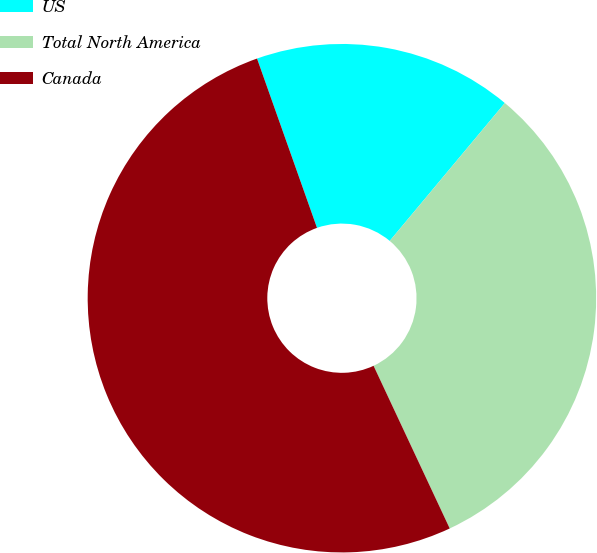Convert chart to OTSL. <chart><loc_0><loc_0><loc_500><loc_500><pie_chart><fcel>US<fcel>Total North America<fcel>Canada<nl><fcel>16.49%<fcel>31.96%<fcel>51.55%<nl></chart> 